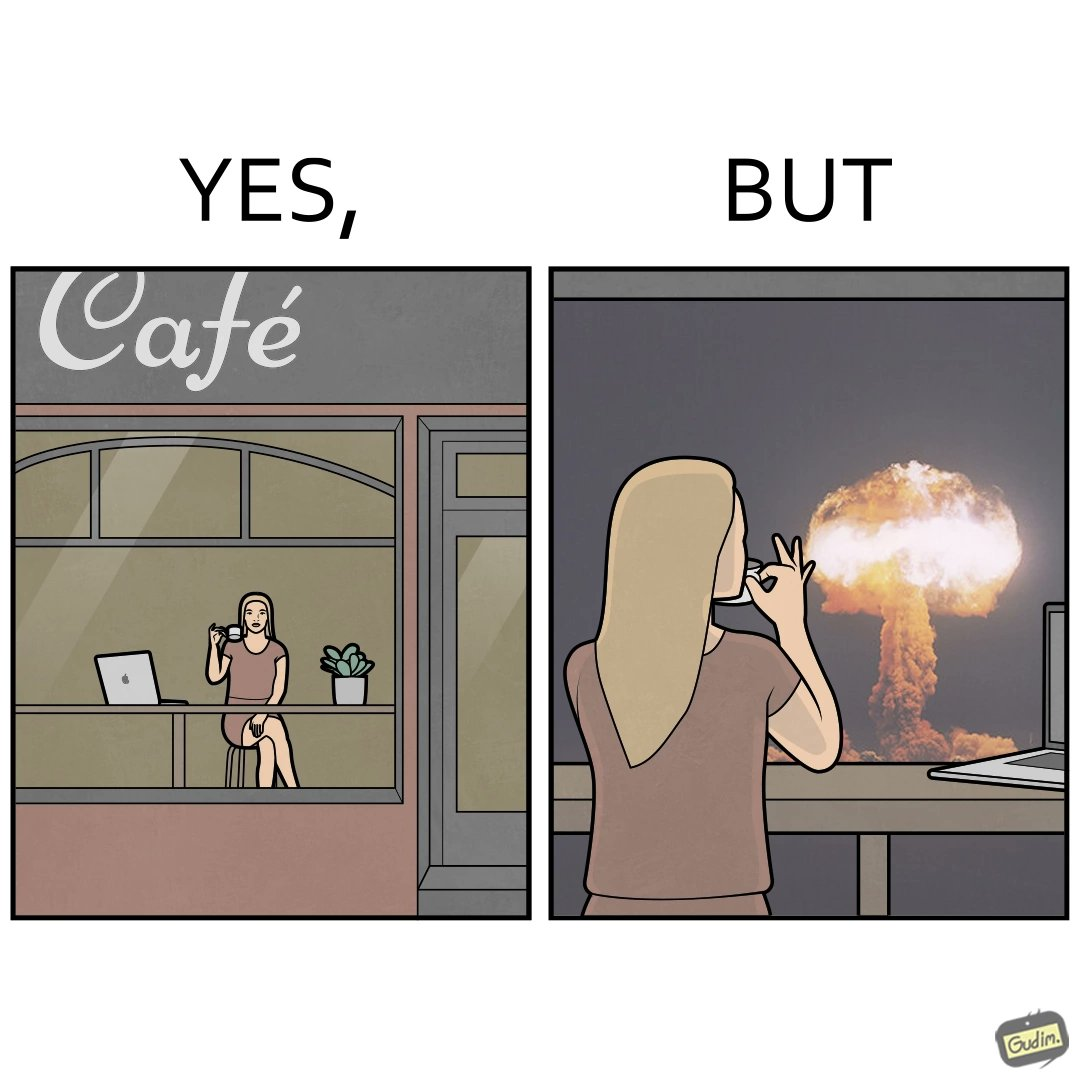What is shown in the left half versus the right half of this image? In the left part of the image: A woman sipping from a cup in a cafe with her laptop In the right part of the image: A woman sipping from a cup while looking at a nuclear blast from her desk 